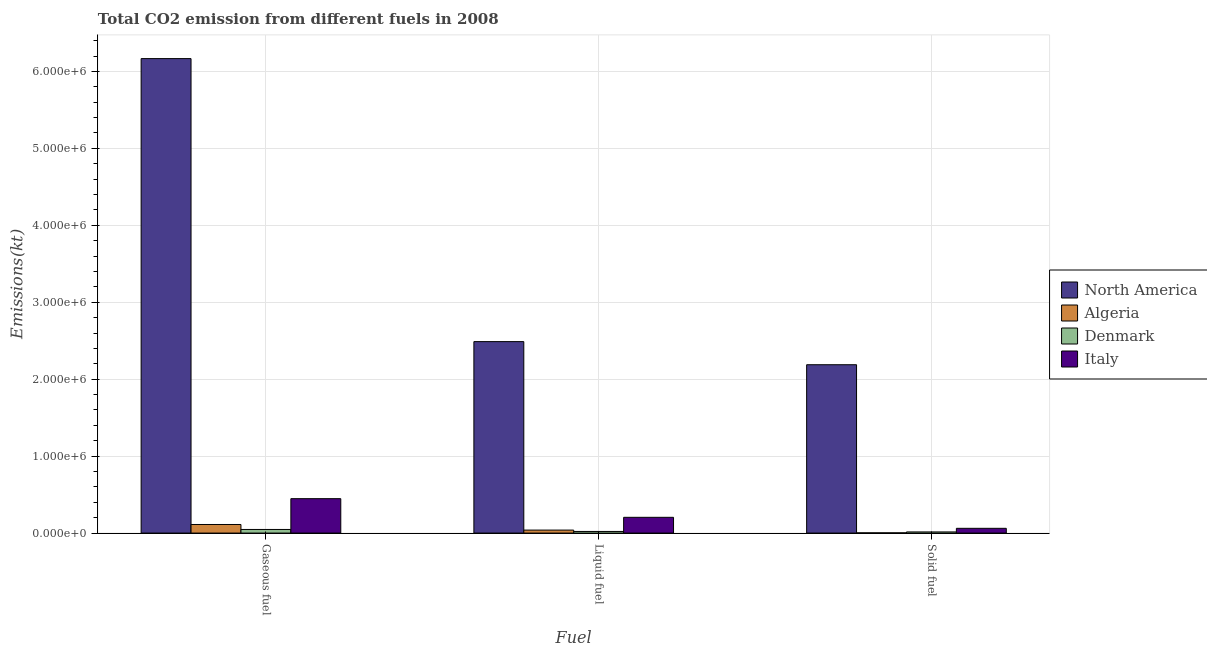How many different coloured bars are there?
Ensure brevity in your answer.  4. Are the number of bars on each tick of the X-axis equal?
Offer a very short reply. Yes. What is the label of the 1st group of bars from the left?
Give a very brief answer. Gaseous fuel. What is the amount of co2 emissions from liquid fuel in Algeria?
Ensure brevity in your answer.  3.89e+04. Across all countries, what is the maximum amount of co2 emissions from gaseous fuel?
Your answer should be compact. 6.17e+06. Across all countries, what is the minimum amount of co2 emissions from liquid fuel?
Ensure brevity in your answer.  2.12e+04. In which country was the amount of co2 emissions from gaseous fuel maximum?
Provide a short and direct response. North America. In which country was the amount of co2 emissions from solid fuel minimum?
Give a very brief answer. Algeria. What is the total amount of co2 emissions from gaseous fuel in the graph?
Make the answer very short. 6.77e+06. What is the difference between the amount of co2 emissions from solid fuel in North America and that in Denmark?
Give a very brief answer. 2.17e+06. What is the difference between the amount of co2 emissions from liquid fuel in Italy and the amount of co2 emissions from solid fuel in Algeria?
Offer a terse response. 2.02e+05. What is the average amount of co2 emissions from liquid fuel per country?
Your answer should be very brief. 6.88e+05. What is the difference between the amount of co2 emissions from gaseous fuel and amount of co2 emissions from liquid fuel in North America?
Give a very brief answer. 3.68e+06. In how many countries, is the amount of co2 emissions from liquid fuel greater than 800000 kt?
Keep it short and to the point. 1. What is the ratio of the amount of co2 emissions from liquid fuel in Algeria to that in North America?
Your response must be concise. 0.02. Is the amount of co2 emissions from solid fuel in Italy less than that in Algeria?
Provide a succinct answer. No. What is the difference between the highest and the second highest amount of co2 emissions from liquid fuel?
Provide a short and direct response. 2.28e+06. What is the difference between the highest and the lowest amount of co2 emissions from liquid fuel?
Your answer should be very brief. 2.47e+06. Is the sum of the amount of co2 emissions from solid fuel in North America and Italy greater than the maximum amount of co2 emissions from liquid fuel across all countries?
Ensure brevity in your answer.  No. What does the 4th bar from the left in Liquid fuel represents?
Your answer should be very brief. Italy. Is it the case that in every country, the sum of the amount of co2 emissions from gaseous fuel and amount of co2 emissions from liquid fuel is greater than the amount of co2 emissions from solid fuel?
Offer a terse response. Yes. How many bars are there?
Offer a very short reply. 12. What is the difference between two consecutive major ticks on the Y-axis?
Your response must be concise. 1.00e+06. Does the graph contain any zero values?
Your response must be concise. No. Does the graph contain grids?
Your answer should be very brief. Yes. How many legend labels are there?
Your answer should be very brief. 4. What is the title of the graph?
Make the answer very short. Total CO2 emission from different fuels in 2008. Does "Latin America(all income levels)" appear as one of the legend labels in the graph?
Make the answer very short. No. What is the label or title of the X-axis?
Your response must be concise. Fuel. What is the label or title of the Y-axis?
Your answer should be very brief. Emissions(kt). What is the Emissions(kt) of North America in Gaseous fuel?
Keep it short and to the point. 6.17e+06. What is the Emissions(kt) of Algeria in Gaseous fuel?
Ensure brevity in your answer.  1.12e+05. What is the Emissions(kt) in Denmark in Gaseous fuel?
Give a very brief answer. 4.70e+04. What is the Emissions(kt) in Italy in Gaseous fuel?
Your answer should be very brief. 4.47e+05. What is the Emissions(kt) of North America in Liquid fuel?
Ensure brevity in your answer.  2.49e+06. What is the Emissions(kt) of Algeria in Liquid fuel?
Provide a short and direct response. 3.89e+04. What is the Emissions(kt) of Denmark in Liquid fuel?
Your response must be concise. 2.12e+04. What is the Emissions(kt) of Italy in Liquid fuel?
Make the answer very short. 2.05e+05. What is the Emissions(kt) in North America in Solid fuel?
Your response must be concise. 2.19e+06. What is the Emissions(kt) of Algeria in Solid fuel?
Your response must be concise. 2907.93. What is the Emissions(kt) of Denmark in Solid fuel?
Your response must be concise. 1.49e+04. What is the Emissions(kt) in Italy in Solid fuel?
Give a very brief answer. 6.18e+04. Across all Fuel, what is the maximum Emissions(kt) of North America?
Provide a succinct answer. 6.17e+06. Across all Fuel, what is the maximum Emissions(kt) in Algeria?
Give a very brief answer. 1.12e+05. Across all Fuel, what is the maximum Emissions(kt) in Denmark?
Provide a short and direct response. 4.70e+04. Across all Fuel, what is the maximum Emissions(kt) of Italy?
Ensure brevity in your answer.  4.47e+05. Across all Fuel, what is the minimum Emissions(kt) in North America?
Your answer should be very brief. 2.19e+06. Across all Fuel, what is the minimum Emissions(kt) of Algeria?
Your response must be concise. 2907.93. Across all Fuel, what is the minimum Emissions(kt) in Denmark?
Provide a short and direct response. 1.49e+04. Across all Fuel, what is the minimum Emissions(kt) in Italy?
Provide a short and direct response. 6.18e+04. What is the total Emissions(kt) of North America in the graph?
Provide a succinct answer. 1.08e+07. What is the total Emissions(kt) in Algeria in the graph?
Ensure brevity in your answer.  1.53e+05. What is the total Emissions(kt) of Denmark in the graph?
Provide a short and direct response. 8.30e+04. What is the total Emissions(kt) of Italy in the graph?
Your answer should be very brief. 7.14e+05. What is the difference between the Emissions(kt) of North America in Gaseous fuel and that in Liquid fuel?
Your answer should be very brief. 3.68e+06. What is the difference between the Emissions(kt) of Algeria in Gaseous fuel and that in Liquid fuel?
Your answer should be very brief. 7.27e+04. What is the difference between the Emissions(kt) in Denmark in Gaseous fuel and that in Liquid fuel?
Provide a short and direct response. 2.58e+04. What is the difference between the Emissions(kt) of Italy in Gaseous fuel and that in Liquid fuel?
Provide a succinct answer. 2.42e+05. What is the difference between the Emissions(kt) of North America in Gaseous fuel and that in Solid fuel?
Keep it short and to the point. 3.98e+06. What is the difference between the Emissions(kt) in Algeria in Gaseous fuel and that in Solid fuel?
Your response must be concise. 1.09e+05. What is the difference between the Emissions(kt) of Denmark in Gaseous fuel and that in Solid fuel?
Provide a short and direct response. 3.21e+04. What is the difference between the Emissions(kt) in Italy in Gaseous fuel and that in Solid fuel?
Your answer should be very brief. 3.85e+05. What is the difference between the Emissions(kt) in North America in Liquid fuel and that in Solid fuel?
Your answer should be compact. 3.01e+05. What is the difference between the Emissions(kt) in Algeria in Liquid fuel and that in Solid fuel?
Provide a succinct answer. 3.59e+04. What is the difference between the Emissions(kt) in Denmark in Liquid fuel and that in Solid fuel?
Provide a succinct answer. 6288.9. What is the difference between the Emissions(kt) in Italy in Liquid fuel and that in Solid fuel?
Provide a short and direct response. 1.43e+05. What is the difference between the Emissions(kt) in North America in Gaseous fuel and the Emissions(kt) in Algeria in Liquid fuel?
Provide a short and direct response. 6.13e+06. What is the difference between the Emissions(kt) in North America in Gaseous fuel and the Emissions(kt) in Denmark in Liquid fuel?
Offer a very short reply. 6.15e+06. What is the difference between the Emissions(kt) in North America in Gaseous fuel and the Emissions(kt) in Italy in Liquid fuel?
Provide a succinct answer. 5.96e+06. What is the difference between the Emissions(kt) in Algeria in Gaseous fuel and the Emissions(kt) in Denmark in Liquid fuel?
Ensure brevity in your answer.  9.04e+04. What is the difference between the Emissions(kt) in Algeria in Gaseous fuel and the Emissions(kt) in Italy in Liquid fuel?
Provide a succinct answer. -9.31e+04. What is the difference between the Emissions(kt) in Denmark in Gaseous fuel and the Emissions(kt) in Italy in Liquid fuel?
Provide a succinct answer. -1.58e+05. What is the difference between the Emissions(kt) of North America in Gaseous fuel and the Emissions(kt) of Algeria in Solid fuel?
Keep it short and to the point. 6.16e+06. What is the difference between the Emissions(kt) of North America in Gaseous fuel and the Emissions(kt) of Denmark in Solid fuel?
Your answer should be compact. 6.15e+06. What is the difference between the Emissions(kt) of North America in Gaseous fuel and the Emissions(kt) of Italy in Solid fuel?
Offer a very short reply. 6.11e+06. What is the difference between the Emissions(kt) in Algeria in Gaseous fuel and the Emissions(kt) in Denmark in Solid fuel?
Ensure brevity in your answer.  9.67e+04. What is the difference between the Emissions(kt) in Algeria in Gaseous fuel and the Emissions(kt) in Italy in Solid fuel?
Your answer should be very brief. 4.98e+04. What is the difference between the Emissions(kt) in Denmark in Gaseous fuel and the Emissions(kt) in Italy in Solid fuel?
Your answer should be compact. -1.49e+04. What is the difference between the Emissions(kt) of North America in Liquid fuel and the Emissions(kt) of Algeria in Solid fuel?
Your answer should be compact. 2.49e+06. What is the difference between the Emissions(kt) of North America in Liquid fuel and the Emissions(kt) of Denmark in Solid fuel?
Ensure brevity in your answer.  2.47e+06. What is the difference between the Emissions(kt) in North America in Liquid fuel and the Emissions(kt) in Italy in Solid fuel?
Offer a terse response. 2.43e+06. What is the difference between the Emissions(kt) in Algeria in Liquid fuel and the Emissions(kt) in Denmark in Solid fuel?
Your answer should be compact. 2.40e+04. What is the difference between the Emissions(kt) of Algeria in Liquid fuel and the Emissions(kt) of Italy in Solid fuel?
Your response must be concise. -2.30e+04. What is the difference between the Emissions(kt) of Denmark in Liquid fuel and the Emissions(kt) of Italy in Solid fuel?
Offer a terse response. -4.06e+04. What is the average Emissions(kt) of North America per Fuel?
Offer a very short reply. 3.61e+06. What is the average Emissions(kt) of Algeria per Fuel?
Keep it short and to the point. 5.11e+04. What is the average Emissions(kt) of Denmark per Fuel?
Offer a very short reply. 2.77e+04. What is the average Emissions(kt) in Italy per Fuel?
Give a very brief answer. 2.38e+05. What is the difference between the Emissions(kt) of North America and Emissions(kt) of Algeria in Gaseous fuel?
Ensure brevity in your answer.  6.06e+06. What is the difference between the Emissions(kt) of North America and Emissions(kt) of Denmark in Gaseous fuel?
Ensure brevity in your answer.  6.12e+06. What is the difference between the Emissions(kt) in North America and Emissions(kt) in Italy in Gaseous fuel?
Provide a succinct answer. 5.72e+06. What is the difference between the Emissions(kt) in Algeria and Emissions(kt) in Denmark in Gaseous fuel?
Your response must be concise. 6.46e+04. What is the difference between the Emissions(kt) in Algeria and Emissions(kt) in Italy in Gaseous fuel?
Offer a terse response. -3.36e+05. What is the difference between the Emissions(kt) of Denmark and Emissions(kt) of Italy in Gaseous fuel?
Make the answer very short. -4.00e+05. What is the difference between the Emissions(kt) of North America and Emissions(kt) of Algeria in Liquid fuel?
Your answer should be very brief. 2.45e+06. What is the difference between the Emissions(kt) of North America and Emissions(kt) of Denmark in Liquid fuel?
Provide a succinct answer. 2.47e+06. What is the difference between the Emissions(kt) in North America and Emissions(kt) in Italy in Liquid fuel?
Provide a succinct answer. 2.28e+06. What is the difference between the Emissions(kt) in Algeria and Emissions(kt) in Denmark in Liquid fuel?
Provide a succinct answer. 1.77e+04. What is the difference between the Emissions(kt) of Algeria and Emissions(kt) of Italy in Liquid fuel?
Your response must be concise. -1.66e+05. What is the difference between the Emissions(kt) of Denmark and Emissions(kt) of Italy in Liquid fuel?
Make the answer very short. -1.84e+05. What is the difference between the Emissions(kt) of North America and Emissions(kt) of Algeria in Solid fuel?
Your answer should be very brief. 2.19e+06. What is the difference between the Emissions(kt) of North America and Emissions(kt) of Denmark in Solid fuel?
Ensure brevity in your answer.  2.17e+06. What is the difference between the Emissions(kt) in North America and Emissions(kt) in Italy in Solid fuel?
Provide a succinct answer. 2.13e+06. What is the difference between the Emissions(kt) of Algeria and Emissions(kt) of Denmark in Solid fuel?
Offer a terse response. -1.20e+04. What is the difference between the Emissions(kt) of Algeria and Emissions(kt) of Italy in Solid fuel?
Keep it short and to the point. -5.89e+04. What is the difference between the Emissions(kt) of Denmark and Emissions(kt) of Italy in Solid fuel?
Offer a very short reply. -4.69e+04. What is the ratio of the Emissions(kt) of North America in Gaseous fuel to that in Liquid fuel?
Make the answer very short. 2.48. What is the ratio of the Emissions(kt) of Algeria in Gaseous fuel to that in Liquid fuel?
Keep it short and to the point. 2.87. What is the ratio of the Emissions(kt) of Denmark in Gaseous fuel to that in Liquid fuel?
Offer a terse response. 2.22. What is the ratio of the Emissions(kt) of Italy in Gaseous fuel to that in Liquid fuel?
Provide a succinct answer. 2.18. What is the ratio of the Emissions(kt) of North America in Gaseous fuel to that in Solid fuel?
Give a very brief answer. 2.82. What is the ratio of the Emissions(kt) in Algeria in Gaseous fuel to that in Solid fuel?
Offer a terse response. 38.37. What is the ratio of the Emissions(kt) in Denmark in Gaseous fuel to that in Solid fuel?
Ensure brevity in your answer.  3.15. What is the ratio of the Emissions(kt) of Italy in Gaseous fuel to that in Solid fuel?
Your response must be concise. 7.24. What is the ratio of the Emissions(kt) in North America in Liquid fuel to that in Solid fuel?
Keep it short and to the point. 1.14. What is the ratio of the Emissions(kt) in Algeria in Liquid fuel to that in Solid fuel?
Your answer should be compact. 13.36. What is the ratio of the Emissions(kt) of Denmark in Liquid fuel to that in Solid fuel?
Provide a succinct answer. 1.42. What is the ratio of the Emissions(kt) of Italy in Liquid fuel to that in Solid fuel?
Ensure brevity in your answer.  3.31. What is the difference between the highest and the second highest Emissions(kt) in North America?
Your response must be concise. 3.68e+06. What is the difference between the highest and the second highest Emissions(kt) of Algeria?
Your answer should be compact. 7.27e+04. What is the difference between the highest and the second highest Emissions(kt) of Denmark?
Keep it short and to the point. 2.58e+04. What is the difference between the highest and the second highest Emissions(kt) in Italy?
Offer a terse response. 2.42e+05. What is the difference between the highest and the lowest Emissions(kt) in North America?
Make the answer very short. 3.98e+06. What is the difference between the highest and the lowest Emissions(kt) in Algeria?
Provide a succinct answer. 1.09e+05. What is the difference between the highest and the lowest Emissions(kt) of Denmark?
Provide a succinct answer. 3.21e+04. What is the difference between the highest and the lowest Emissions(kt) of Italy?
Ensure brevity in your answer.  3.85e+05. 